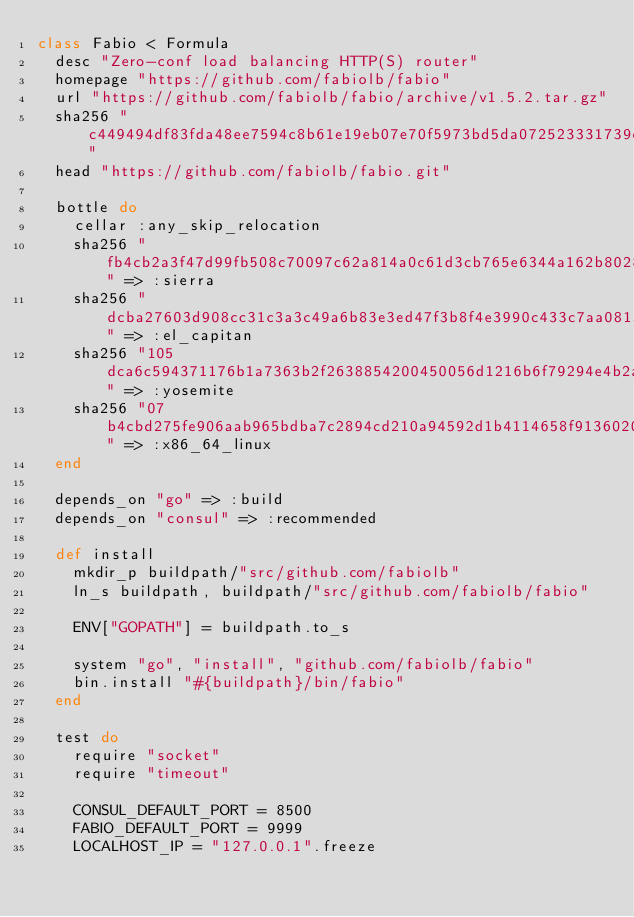Convert code to text. <code><loc_0><loc_0><loc_500><loc_500><_Ruby_>class Fabio < Formula
  desc "Zero-conf load balancing HTTP(S) router"
  homepage "https://github.com/fabiolb/fabio"
  url "https://github.com/fabiolb/fabio/archive/v1.5.2.tar.gz"
  sha256 "c449494df83fda48ee7594c8b61e19eb07e70f5973bd5da072523331739c1ccb"
  head "https://github.com/fabiolb/fabio.git"

  bottle do
    cellar :any_skip_relocation
    sha256 "fb4cb2a3f47d99fb508c70097c62a814a0c61d3cb765e6344a162b8028866f21" => :sierra
    sha256 "dcba27603d908cc31c3a3c49a6b83e3ed47f3b8f4e3990c433c7aa0815bc83df" => :el_capitan
    sha256 "105dca6c594371176b1a7363b2f2638854200450056d1216b6f79294e4b2a25a" => :yosemite
    sha256 "07b4cbd275fe906aab965bdba7c2894cd210a94592d1b4114658f9136020ba13" => :x86_64_linux
  end

  depends_on "go" => :build
  depends_on "consul" => :recommended

  def install
    mkdir_p buildpath/"src/github.com/fabiolb"
    ln_s buildpath, buildpath/"src/github.com/fabiolb/fabio"

    ENV["GOPATH"] = buildpath.to_s

    system "go", "install", "github.com/fabiolb/fabio"
    bin.install "#{buildpath}/bin/fabio"
  end

  test do
    require "socket"
    require "timeout"

    CONSUL_DEFAULT_PORT = 8500
    FABIO_DEFAULT_PORT = 9999
    LOCALHOST_IP = "127.0.0.1".freeze
</code> 